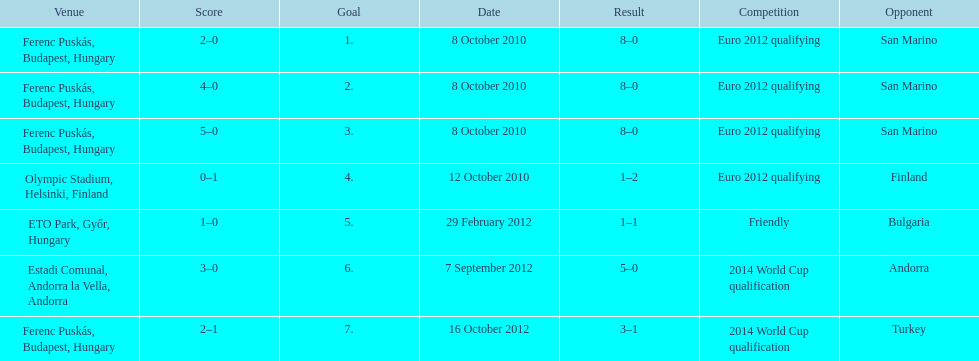How many games did he score but his team lost? 1. 